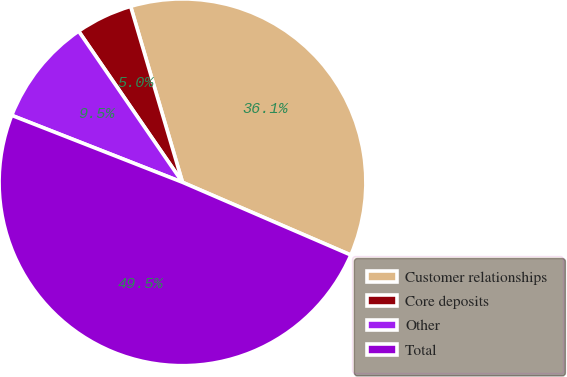Convert chart. <chart><loc_0><loc_0><loc_500><loc_500><pie_chart><fcel>Customer relationships<fcel>Core deposits<fcel>Other<fcel>Total<nl><fcel>36.05%<fcel>5.02%<fcel>9.47%<fcel>49.45%<nl></chart> 